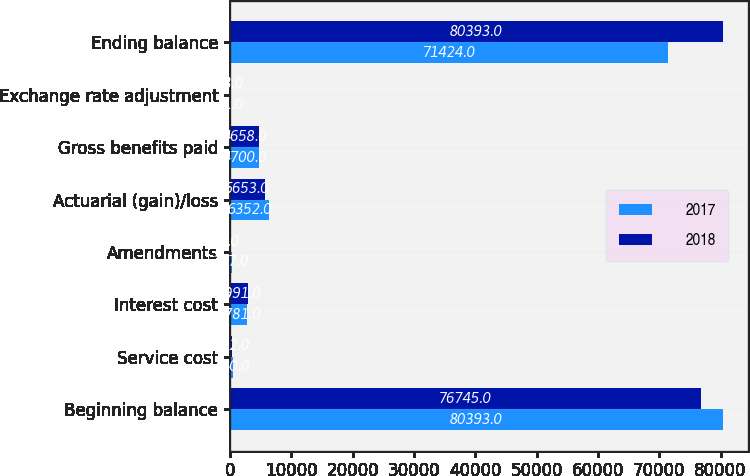<chart> <loc_0><loc_0><loc_500><loc_500><stacked_bar_chart><ecel><fcel>Beginning balance<fcel>Service cost<fcel>Interest cost<fcel>Amendments<fcel>Actuarial (gain)/loss<fcel>Gross benefits paid<fcel>Exchange rate adjustment<fcel>Ending balance<nl><fcel>2017<fcel>80393<fcel>430<fcel>2781<fcel>377<fcel>6352<fcel>4700<fcel>21<fcel>71424<nl><fcel>2018<fcel>76745<fcel>402<fcel>2991<fcel>7<fcel>5653<fcel>4658<fcel>18<fcel>80393<nl></chart> 